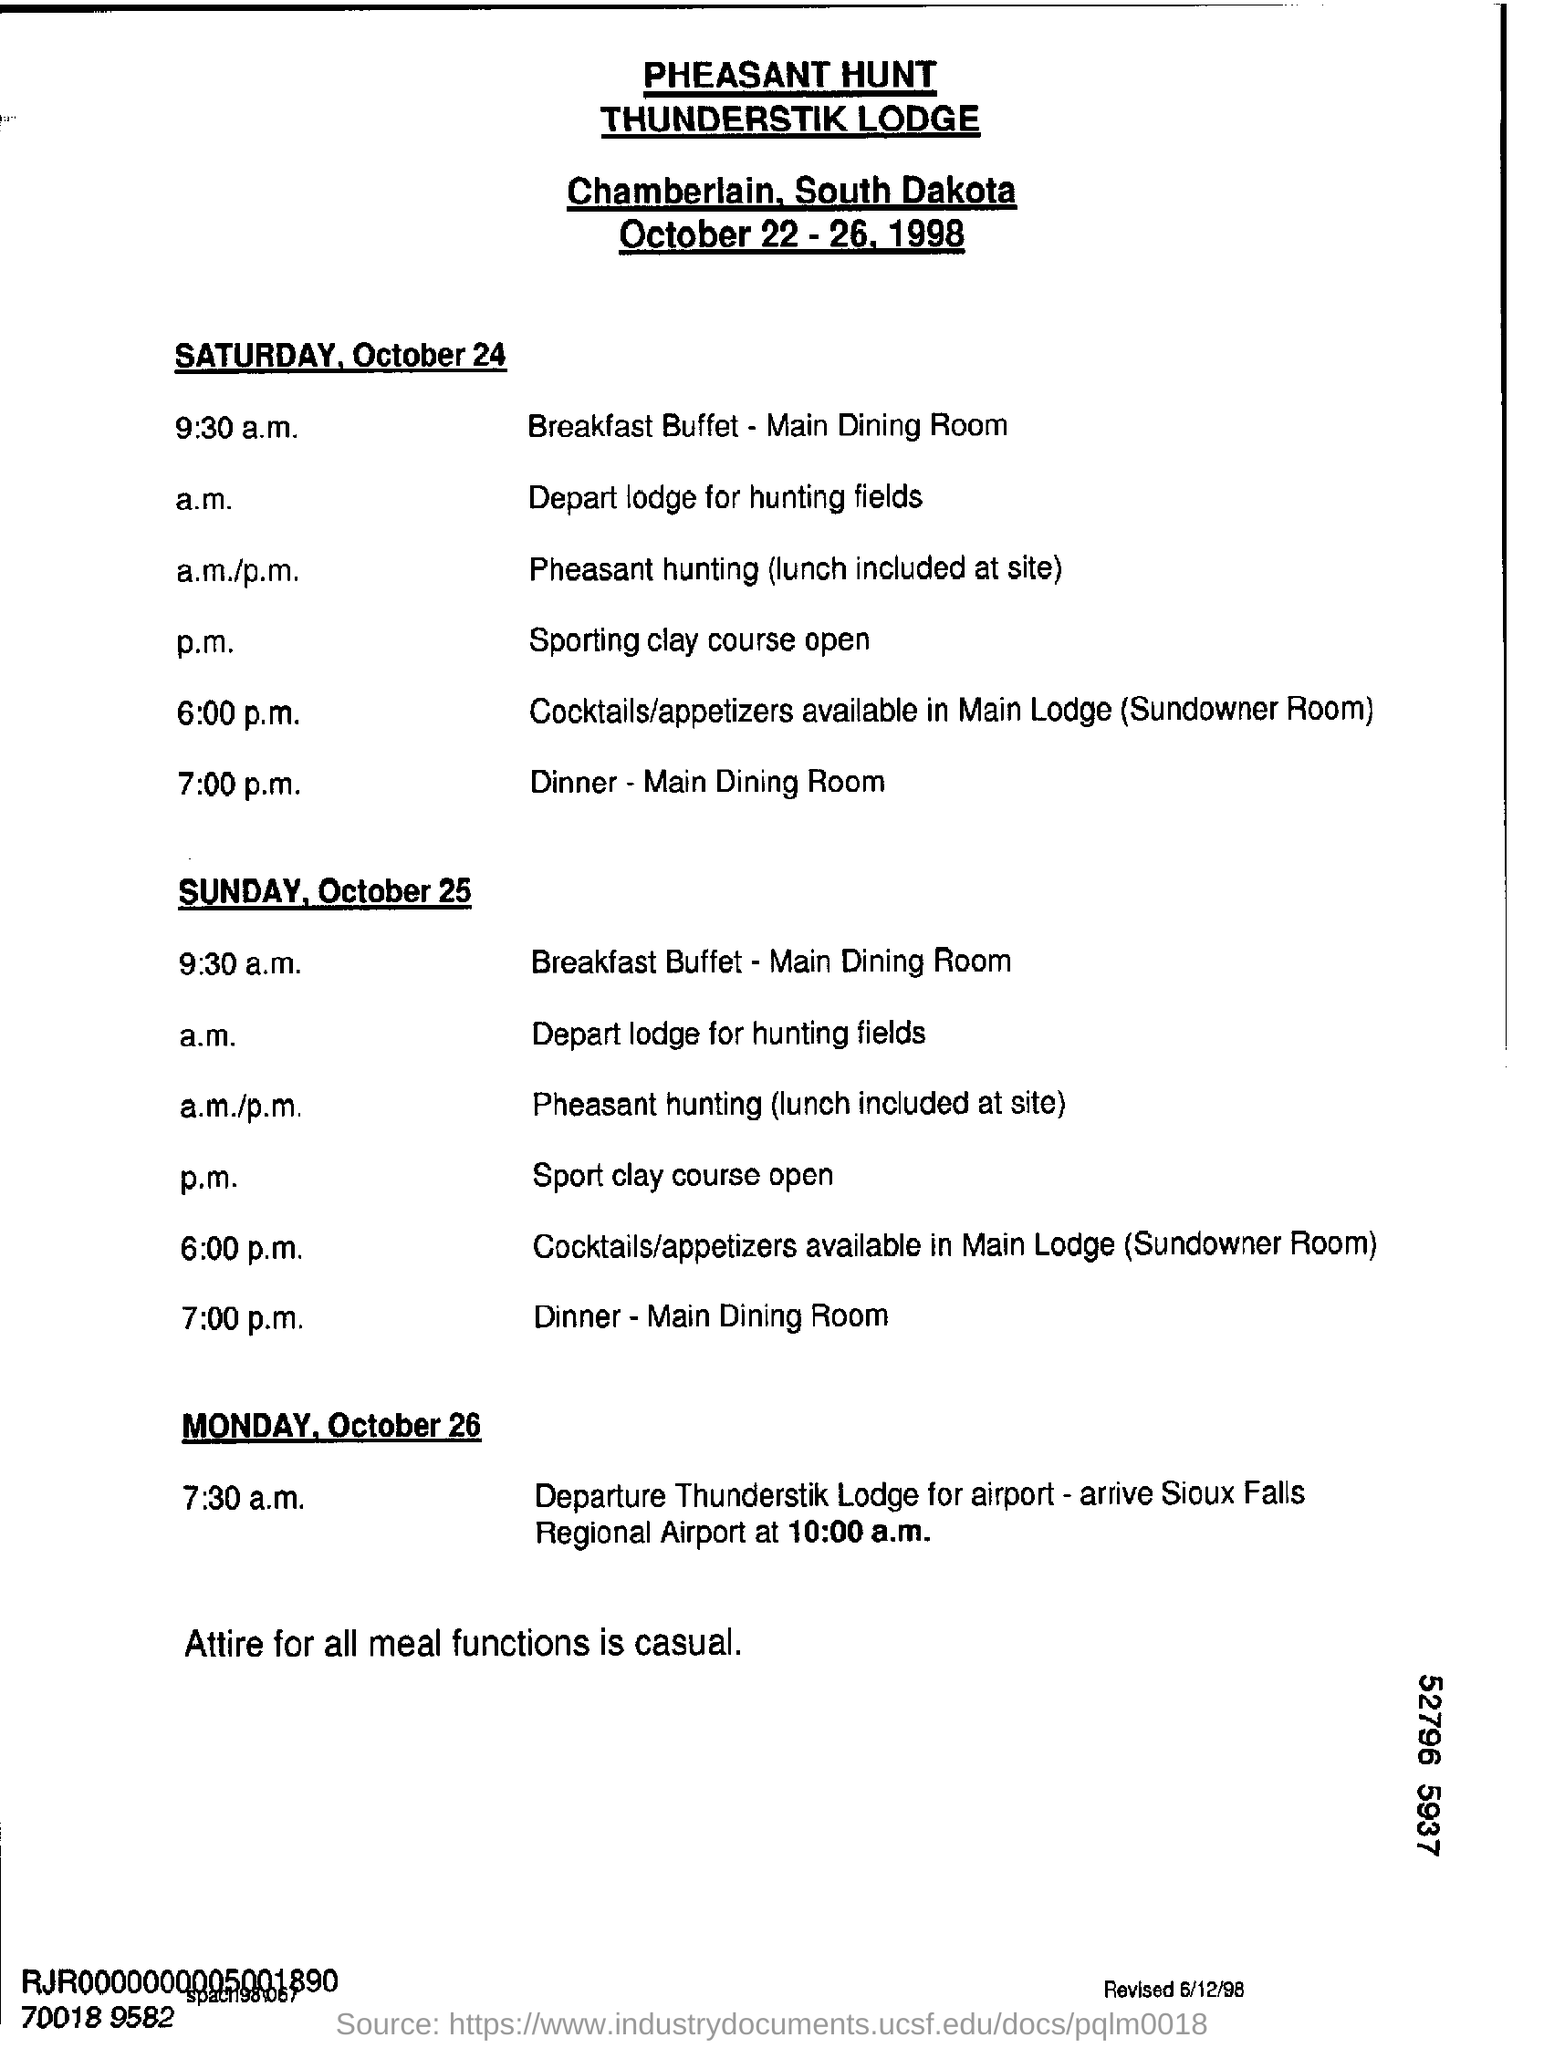When will they arrive at Sioux Regional Airport?
Your answer should be very brief. 10:00 a.m. 